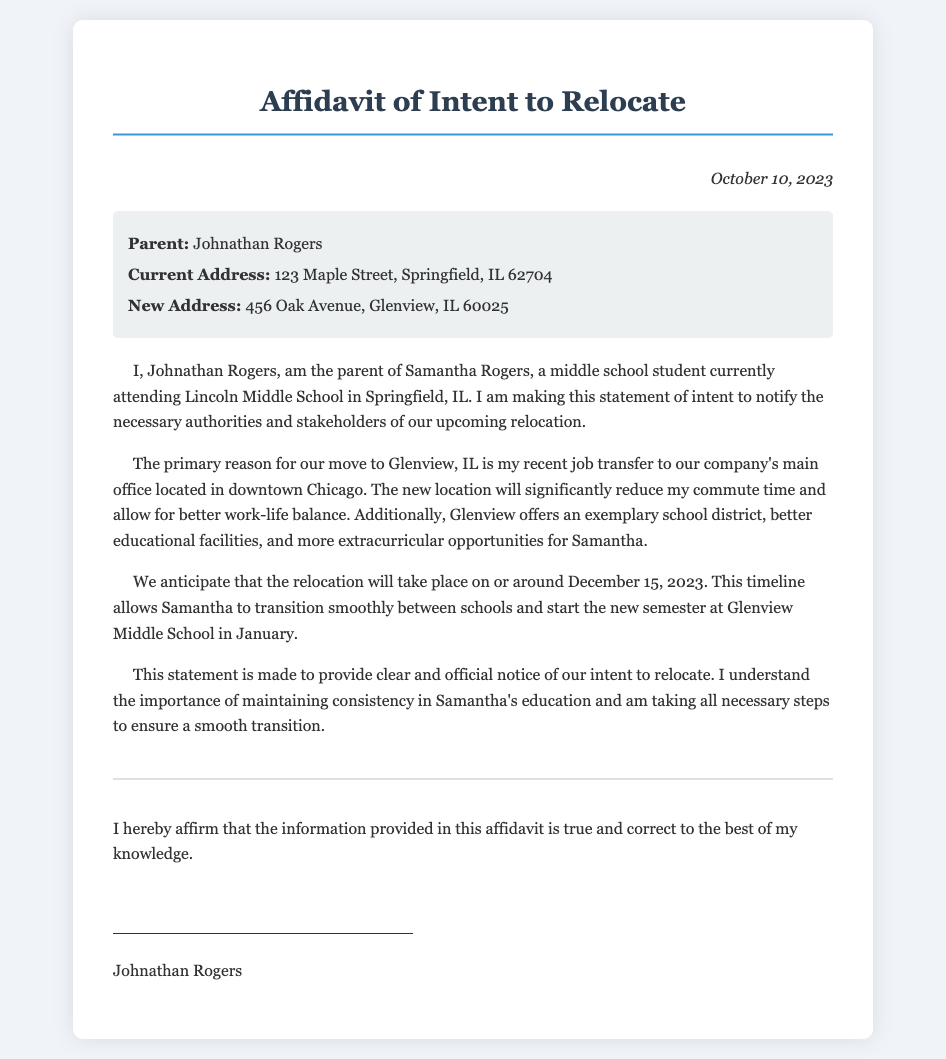What is the parent’s name? The parent’s name is explicitly stated in the document as Johnathan Rogers.
Answer: Johnathan Rogers What is the current address? The current address is listed as 123 Maple Street, Springfield, IL 62704 in the affidavit.
Answer: 123 Maple Street, Springfield, IL 62704 What is the new address? The new address, as mentioned in the document, is 456 Oak Avenue, Glenview, IL 60025.
Answer: 456 Oak Avenue, Glenview, IL 60025 What is the anticipated relocation date? The anticipated relocation date is specified as on or around December 15, 2023.
Answer: December 15, 2023 What school is Samantha currently attending? The document states that Samantha is currently attending Lincoln Middle School.
Answer: Lincoln Middle School What is the primary reason for the move? The primary reason for the move is stated as a job transfer to the company's main office in downtown Chicago.
Answer: Job transfer What benefits does Glenview offer? The document mentions that Glenview offers an exemplary school district, better educational facilities, and more extracurricular opportunities.
Answer: Exemplary school district What is the aim of this affidavit? The aim of the affidavit is to provide clear and official notice of the intent to relocate.
Answer: Clear notice What does the parent affirm about the information? The parent affirms that the information provided in this affidavit is true and correct to the best of his knowledge.
Answer: True and correct 